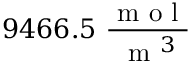Convert formula to latex. <formula><loc_0><loc_0><loc_500><loc_500>9 4 6 6 . 5 \ \frac { m o l } { m ^ { 3 } }</formula> 